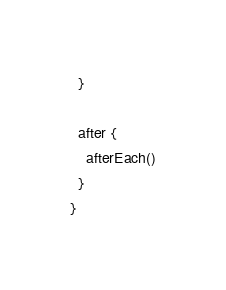<code> <loc_0><loc_0><loc_500><loc_500><_Scala_>  }

  after {
    afterEach()
  }
}
</code> 